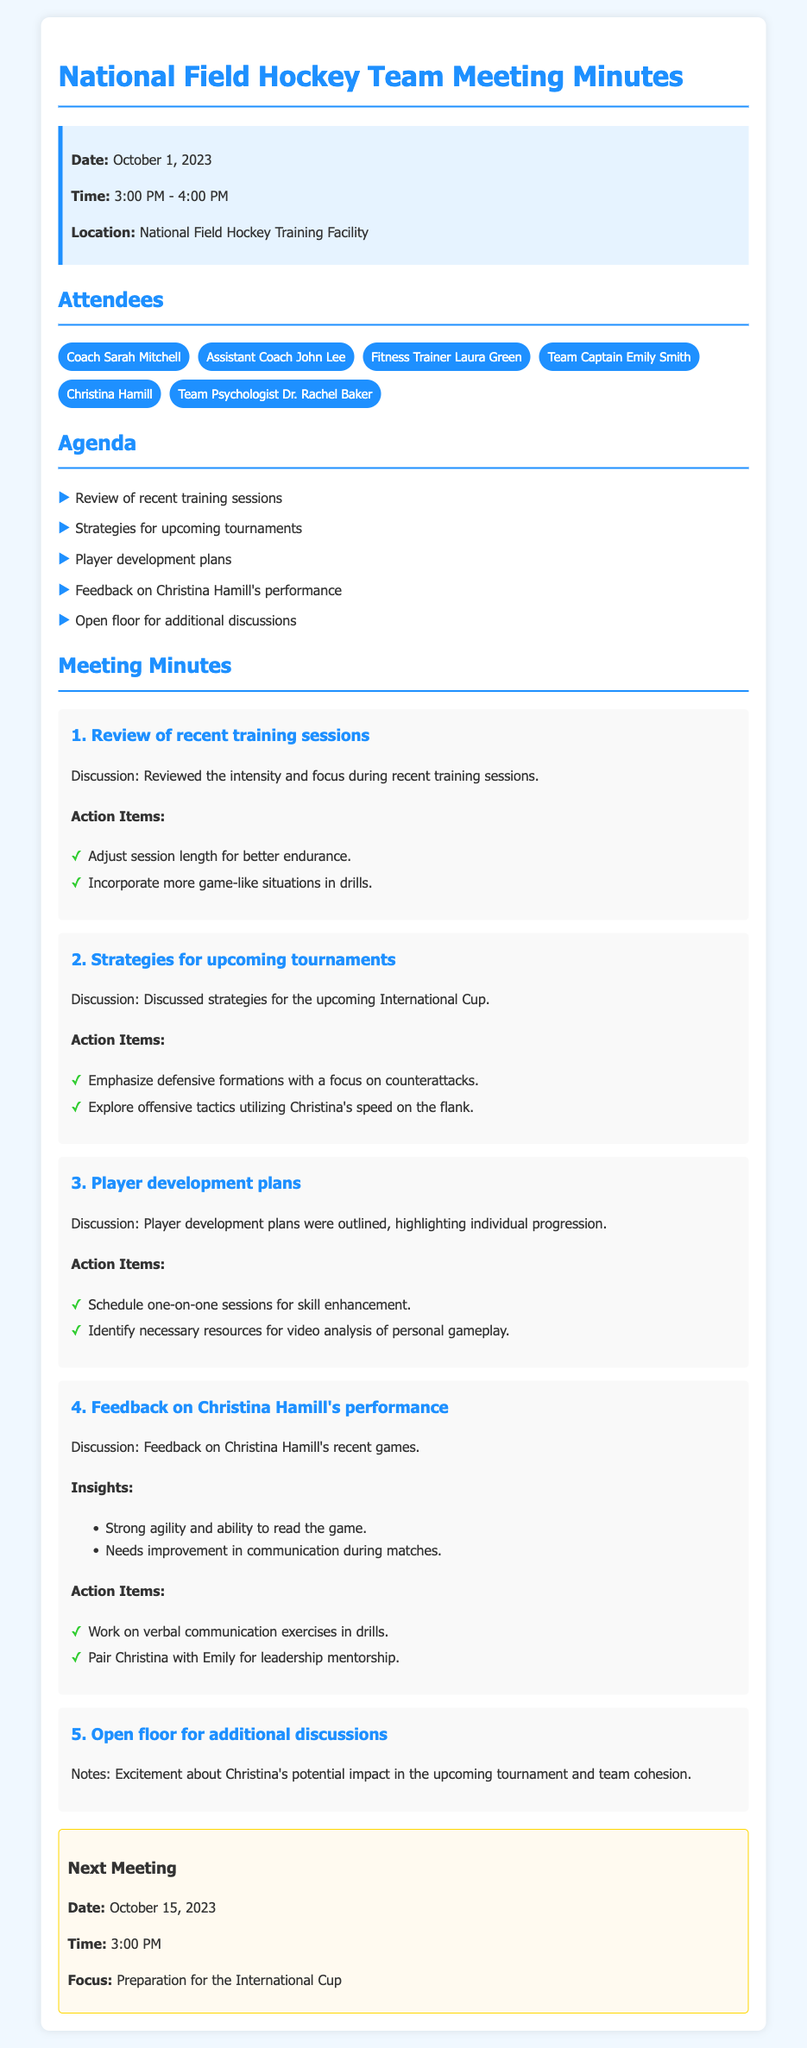What is the date of the meeting? The date of the meeting is stated in the meeting info section.
Answer: October 1, 2023 Who are the attendees at the meeting? The attendees include all individuals listed under the attendees section.
Answer: Coach Sarah Mitchell, Assistant Coach John Lee, Fitness Trainer Laura Green, Team Captain Emily Smith, Christina Hamill, Team Psychologist Dr. Rachel Baker What is one of the strategies discussed for upcoming tournaments? One strategy is specifically mentioned under the strategies section of the minutes.
Answer: Emphasize defensive formations with a focus on counterattacks What feedback was given on Christina Hamill's performance? Feedback can be found in the section dedicated to Christina Hamill's performance feedback.
Answer: Strong agility and ability to read the game When is the next meeting scheduled? The next meeting date is found in the next meeting section.
Answer: October 15, 2023 What is the focus of the next meeting? The focus of the next meeting is outlined in the next meeting section.
Answer: Preparation for the International Cup What action item involves verbal communication? This action item is mentioned in the feedback section regarding Christina Hamill.
Answer: Work on verbal communication exercises in drills What was discussed in the open floor part of the meeting? Notes from the open floor section highlight general sentiments about Christina and team dynamics.
Answer: Excitement about Christina's potential impact in the upcoming tournament and team cohesion 